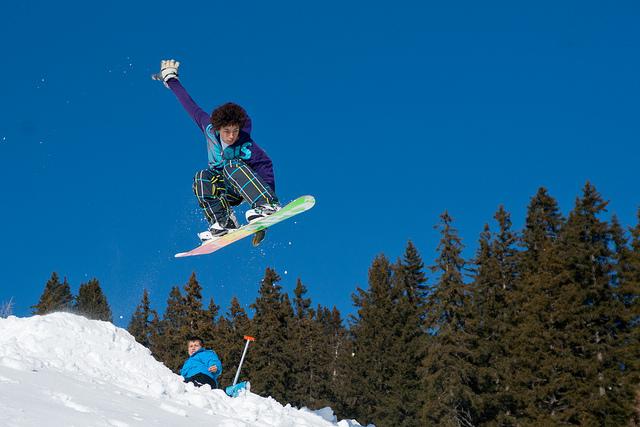What is the person's arm in the air behind them?
Keep it brief. Balance. What is on their feet?
Short answer required. Snowboard. Is that smog in the background?
Short answer required. No. What are these people riding?
Short answer required. Snowboard. What season is this?
Give a very brief answer. Winter. 